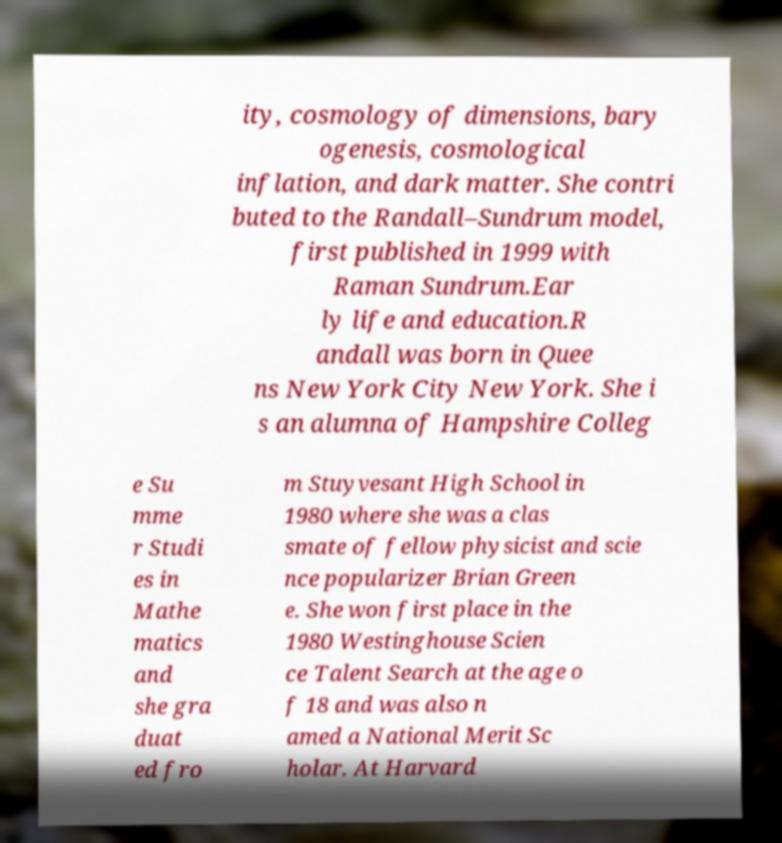Please identify and transcribe the text found in this image. ity, cosmology of dimensions, bary ogenesis, cosmological inflation, and dark matter. She contri buted to the Randall–Sundrum model, first published in 1999 with Raman Sundrum.Ear ly life and education.R andall was born in Quee ns New York City New York. She i s an alumna of Hampshire Colleg e Su mme r Studi es in Mathe matics and she gra duat ed fro m Stuyvesant High School in 1980 where she was a clas smate of fellow physicist and scie nce popularizer Brian Green e. She won first place in the 1980 Westinghouse Scien ce Talent Search at the age o f 18 and was also n amed a National Merit Sc holar. At Harvard 